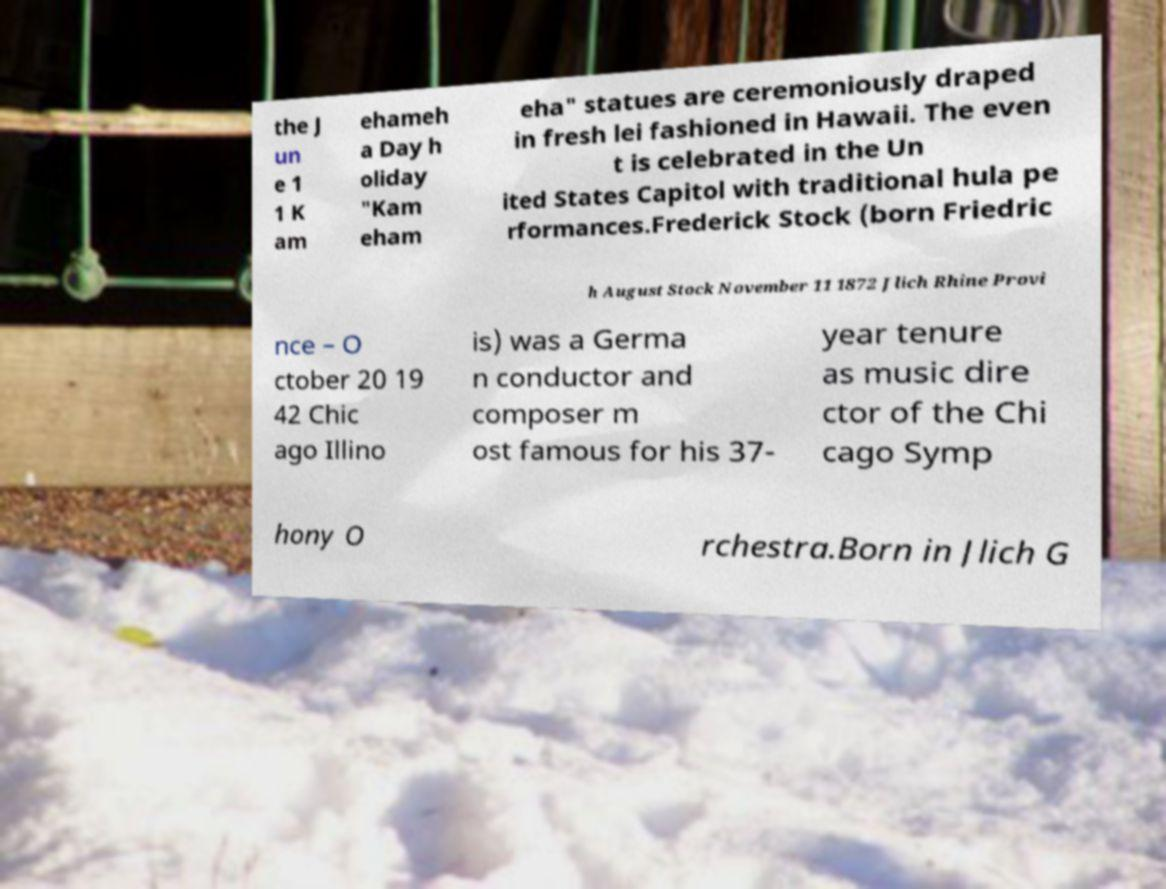Please read and relay the text visible in this image. What does it say? the J un e 1 1 K am ehameh a Day h oliday "Kam eham eha" statues are ceremoniously draped in fresh lei fashioned in Hawaii. The even t is celebrated in the Un ited States Capitol with traditional hula pe rformances.Frederick Stock (born Friedric h August Stock November 11 1872 Jlich Rhine Provi nce – O ctober 20 19 42 Chic ago Illino is) was a Germa n conductor and composer m ost famous for his 37- year tenure as music dire ctor of the Chi cago Symp hony O rchestra.Born in Jlich G 